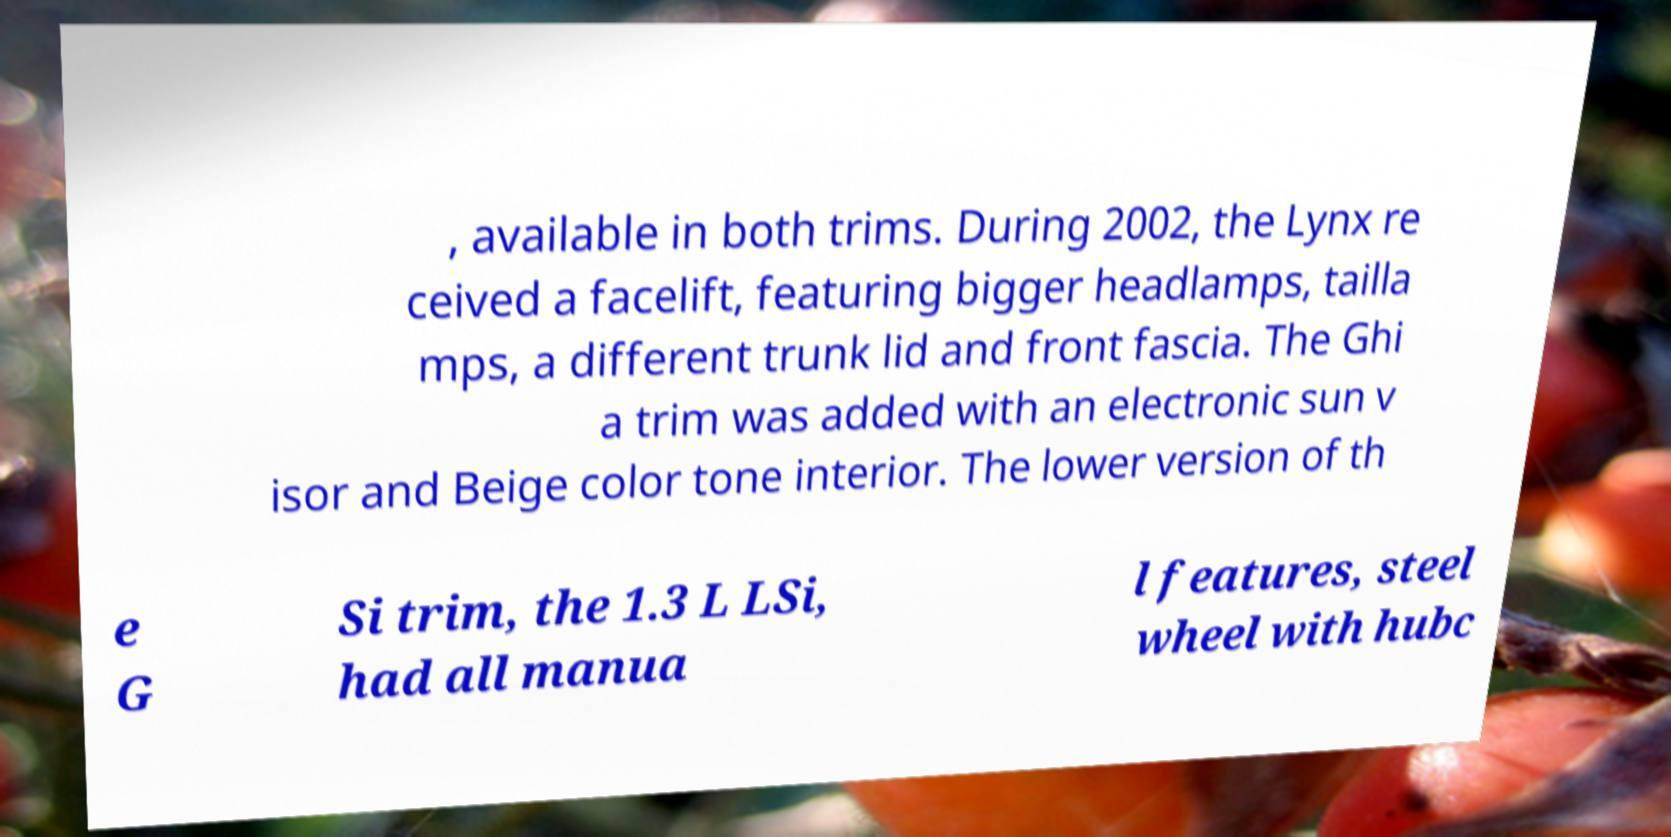Could you extract and type out the text from this image? , available in both trims. During 2002, the Lynx re ceived a facelift, featuring bigger headlamps, tailla mps, a different trunk lid and front fascia. The Ghi a trim was added with an electronic sun v isor and Beige color tone interior. The lower version of th e G Si trim, the 1.3 L LSi, had all manua l features, steel wheel with hubc 